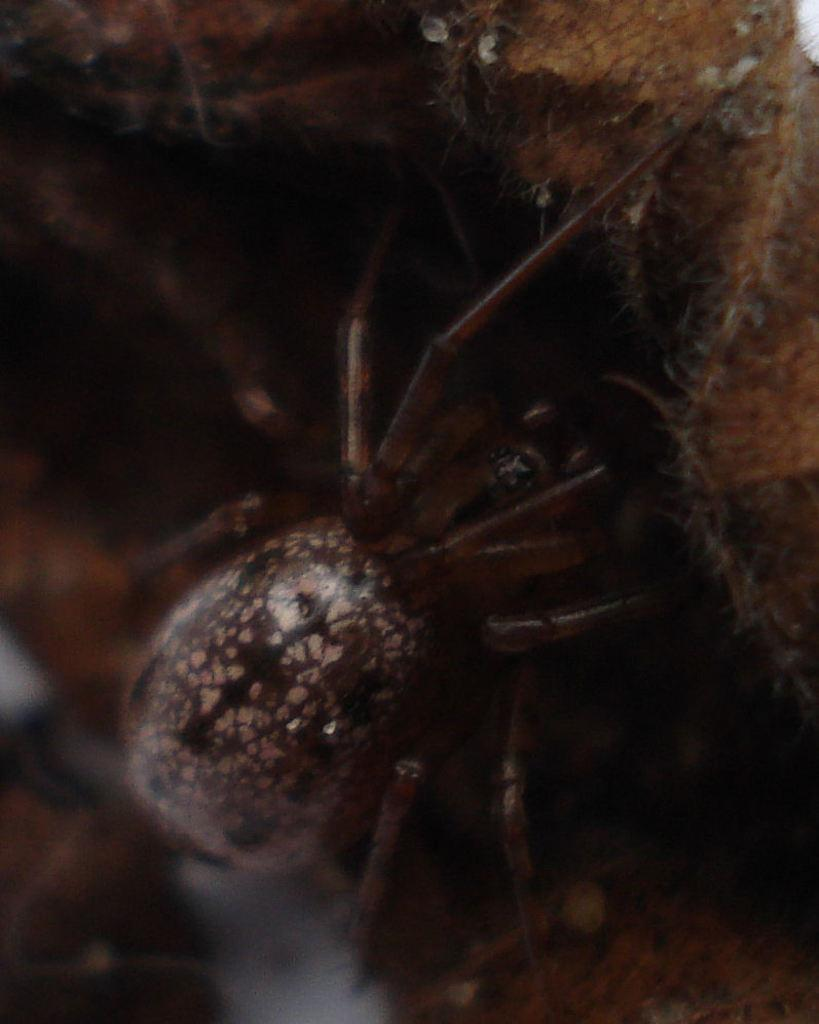What is the main subject in the center of the image? There is an insect in the center of the image. What other object can be seen in the image? There is a rock in the image. How many chairs are visible in the image? There are no chairs present in the image. Can you hear the insect in the image? The image is a visual representation, so there is no sound to hear. 